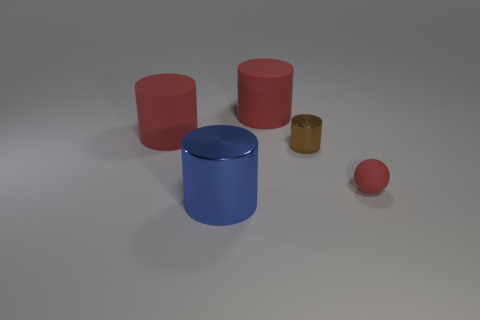Subtract all small brown metallic cylinders. How many cylinders are left? 3 Subtract all brown cylinders. How many cylinders are left? 3 Subtract all cylinders. How many objects are left? 1 Add 1 shiny objects. How many objects exist? 6 Subtract 3 cylinders. How many cylinders are left? 1 Subtract all red spheres. How many red cylinders are left? 2 Subtract all small red matte spheres. Subtract all brown balls. How many objects are left? 4 Add 1 small red rubber spheres. How many small red rubber spheres are left? 2 Add 3 big blue cylinders. How many big blue cylinders exist? 4 Subtract 0 purple blocks. How many objects are left? 5 